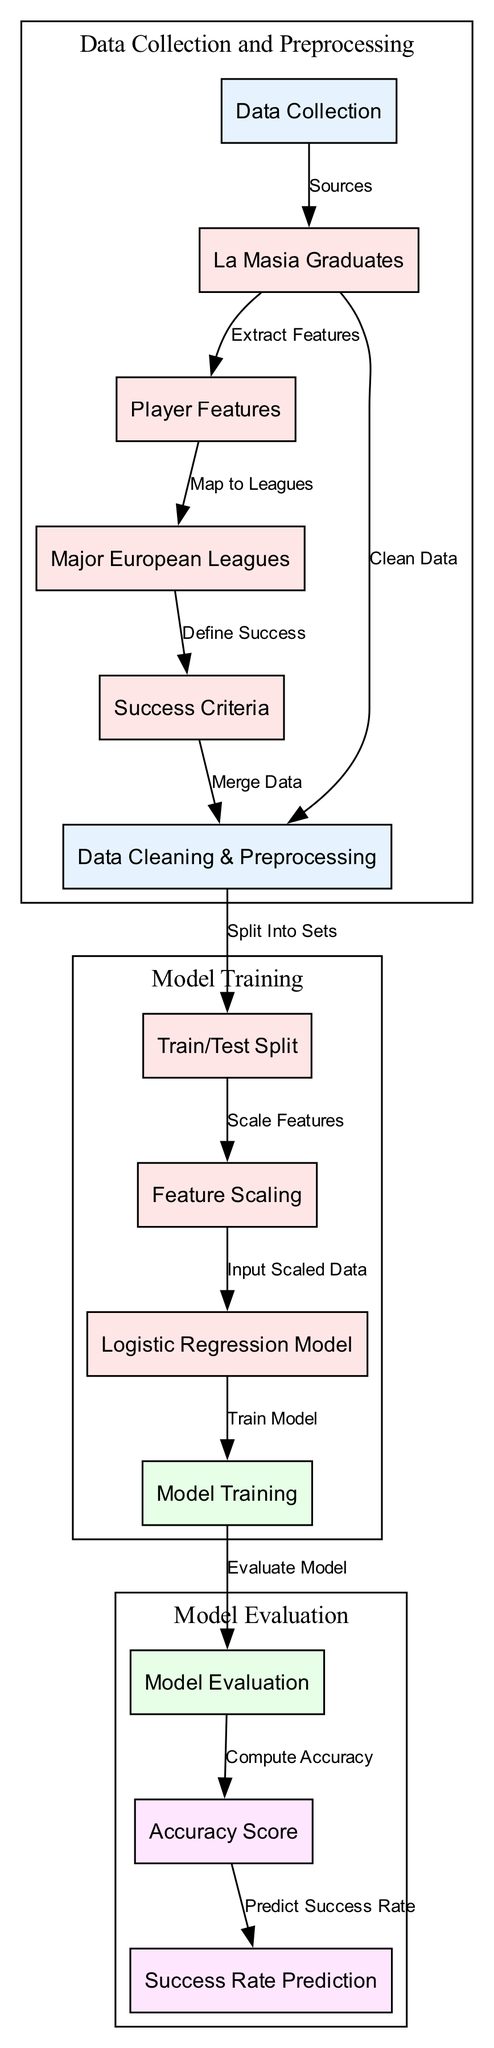What are the first two nodes in the diagram? The first two nodes in the diagram are "Data Collection" and "La Masia Graduates". These nodes represent the initial process involved in gathering data and identifying the players from La Masia.
Answer: Data Collection, La Masia Graduates How many edges are there in the diagram? By counting the connections between the nodes (the directed arrows that represent relationships or processes), there are a total of 12 edges in the diagram.
Answer: 12 What is the output of the model evaluation? The output of the model evaluation node is the "Accuracy Score", as it represents the assessment result from the model's performance.
Answer: Accuracy Score Which node defines the criteria for success? The node that defines the criteria for success is "Success Criteria", which establishes how success is measured for La Masia graduates in the major leagues.
Answer: Success Criteria What follows the feature scaling step? After the feature scaling step, the next step is the "Logistic Regression Model", which utilizes the scaled features for training the model.
Answer: Logistic Regression Model What is the final node in the diagram? The final node in the diagram, representing the end of the process, is "Success Rate Prediction". This node provides predictions based on the trained model.
Answer: Success Rate Prediction How is data cleaned and preprocessed before splitting? The data cleaning and preprocessing are done after merging the data, which involves handling missing values and ensuring data quality before splitting into training and testing sets.
Answer: Clean Data What kind of model is trained in the diagram? The model trained in the diagram is a "Logistic Regression Model", used to predict the success rate of La Masia players based on their features.
Answer: Logistic Regression Model In which subgraph is "Data Collection and Preprocessing" located? "Data Collection and Preprocessing" is located in the first subgraph labeled 'cluster_0', which groups related nodes for clarity in the diagram.
Answer: cluster_0 